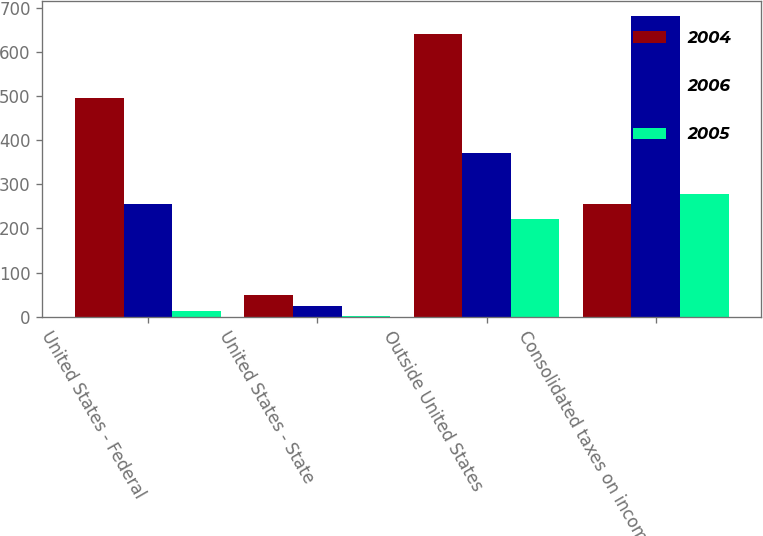<chart> <loc_0><loc_0><loc_500><loc_500><stacked_bar_chart><ecel><fcel>United States - Federal<fcel>United States - State<fcel>Outside United States<fcel>Consolidated taxes on income<nl><fcel>2004<fcel>495<fcel>49<fcel>641<fcel>256<nl><fcel>2006<fcel>256<fcel>24<fcel>372<fcel>682<nl><fcel>2005<fcel>13<fcel>1<fcel>221<fcel>277<nl></chart> 